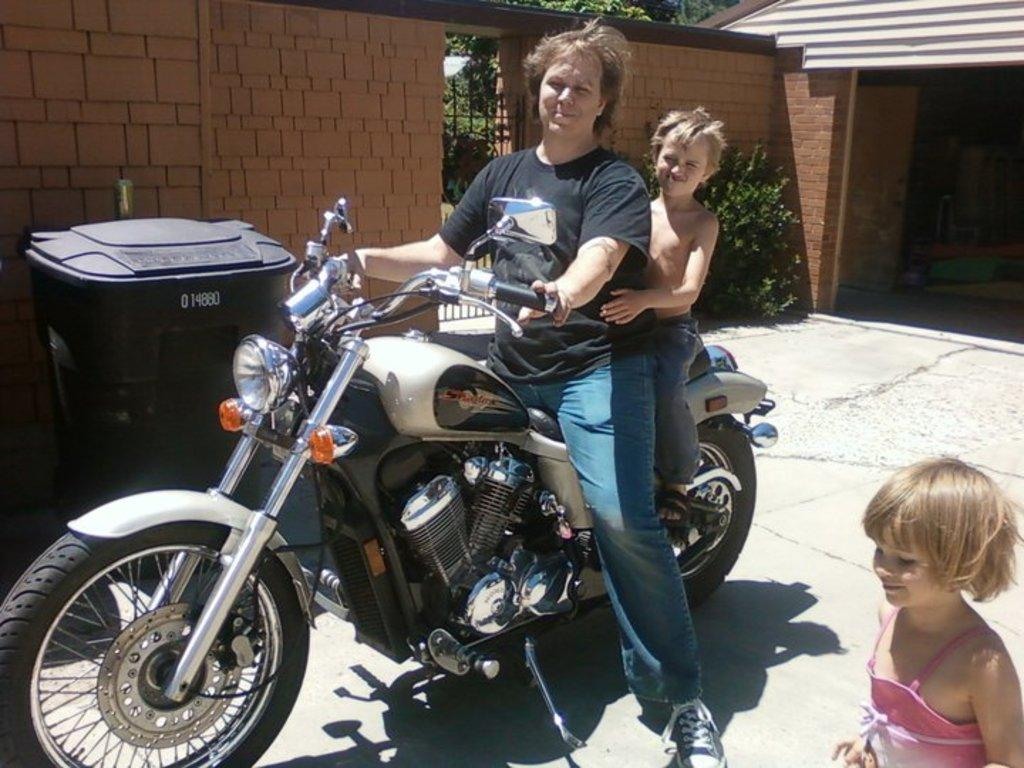Who is present in the image? There is a man in the image. What activity is one of the children engaged in? There is a child sitting on a bike in the image. What is the other child doing in the image? There is another child standing beside the bike in the image. What can be seen in the background of the image? There is a wall, a tank, and a plant in the background of the image. What is the current month in the image? The image does not provide information about the current month. What type of work is the man doing in the image? The image does not show the man engaged in any work-related activity. 